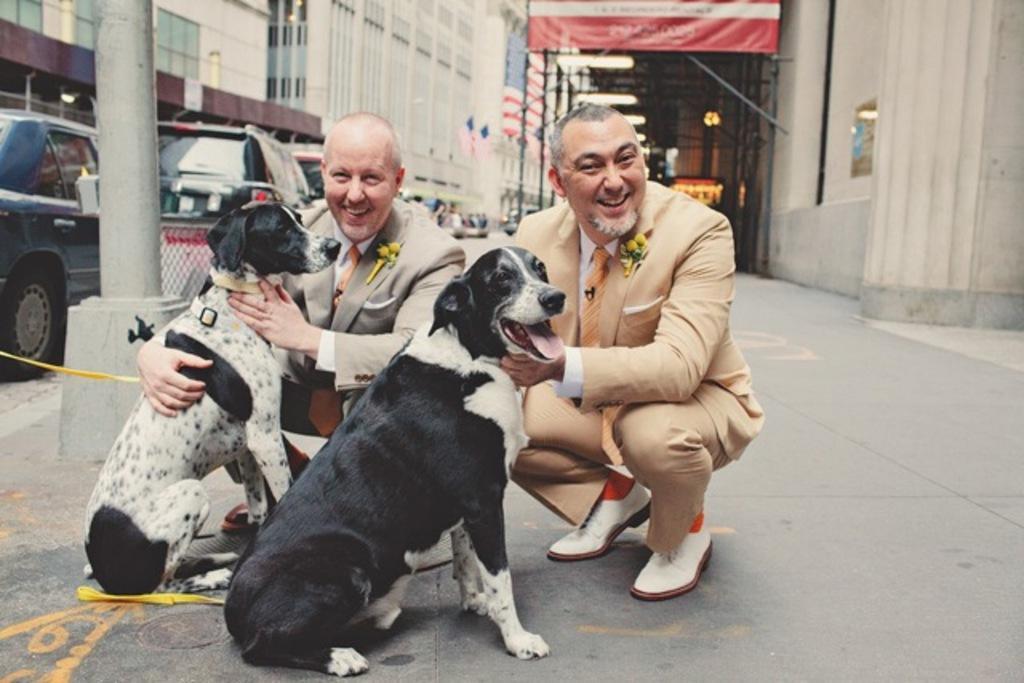How would you summarize this image in a sentence or two? In this picture two guys are holding two dogs and one of them is white and the other is black. In the background we observe many cars and buildings. The picture is taken on a road. 